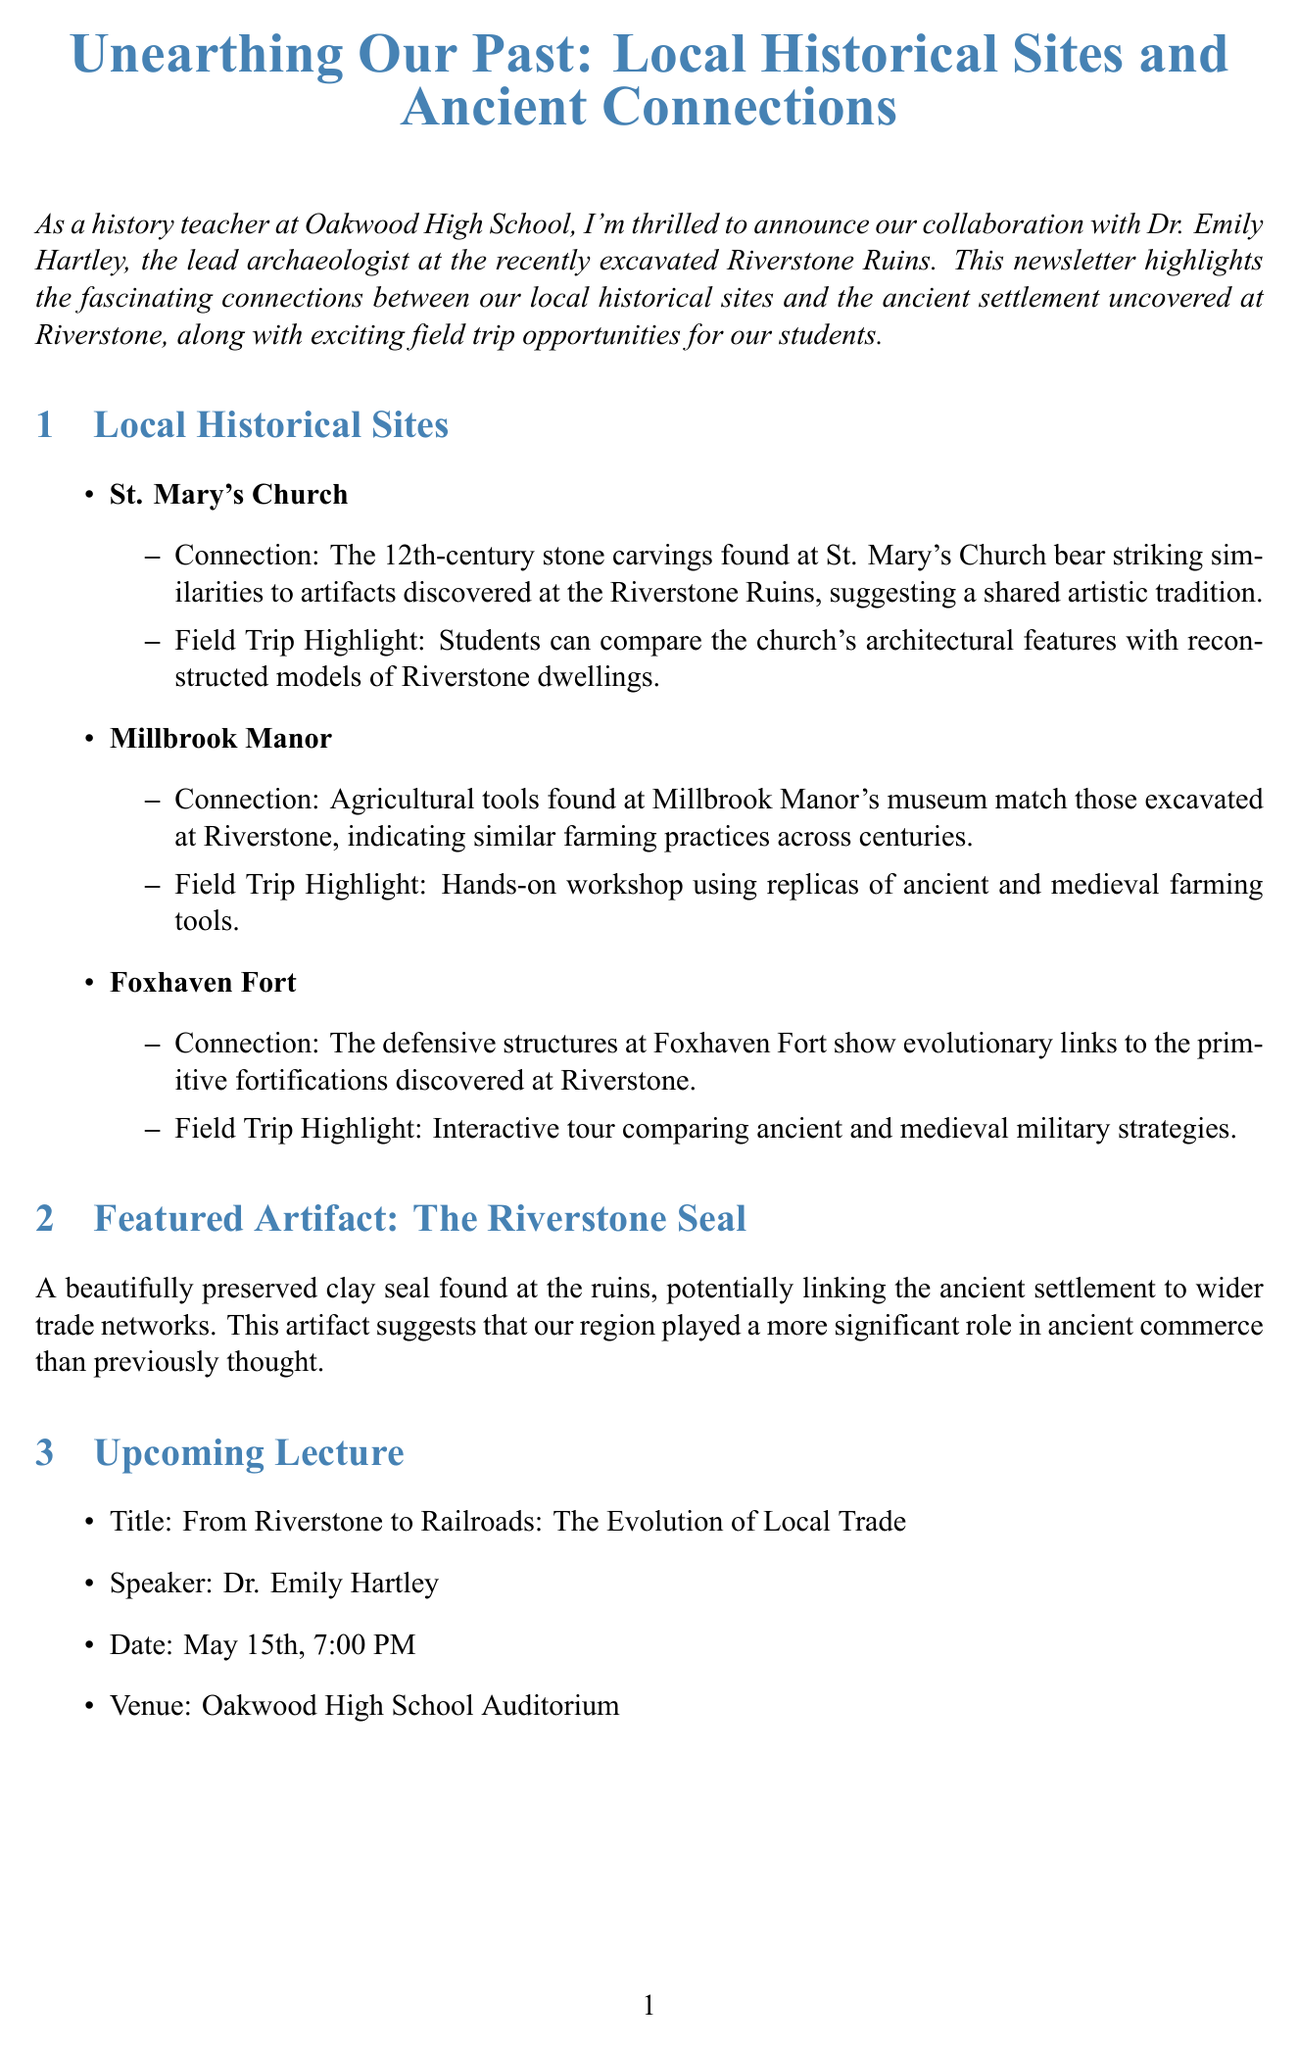What is the title of the newsletter? The title of the newsletter is presented at the top of the document to indicate its main focus.
Answer: Unearthing Our Past: Local Historical Sites and Ancient Connections Who is the lead archaeologist mentioned in the newsletter? The newsletter introduces the archaeologist collaborating with the school, providing relevant credentials and connection to the local history.
Answer: Dr. Emily Hartley What artifact is featured in the newsletter? The document highlights a specific artifact found at the Riverstone Ruins, indicating its importance and context.
Answer: The Riverstone Seal When is the upcoming lecture scheduled? The date of the upcoming lecture is mentioned clearly, providing crucial information about the event's timing.
Answer: May 15th What is the first activity on Day 1 of the field trip itinerary? The itinerary outlines the sequence of proposed activities, making it easy to understand the flow of the field trip.
Answer: Guided tour of Riverstone Ruins with Dr. Hartley How many historical sites are highlighted in the newsletter? The document lists local historical sites, and this question requires counting the entries provided.
Answer: Three What connection is made between St. Mary's Church and the Riverstone Ruins? This requires synthesizing information about the connection between a local site and the archaeological findings mentioned.
Answer: Shared artistic tradition What type of resource is "Comparative Timeline: Riverstone to Modern Day"? The newsletter includes various resources designed for teachers, and this question assesses knowledge of one specific resource type mentioned.
Answer: Interactive digital timeline 